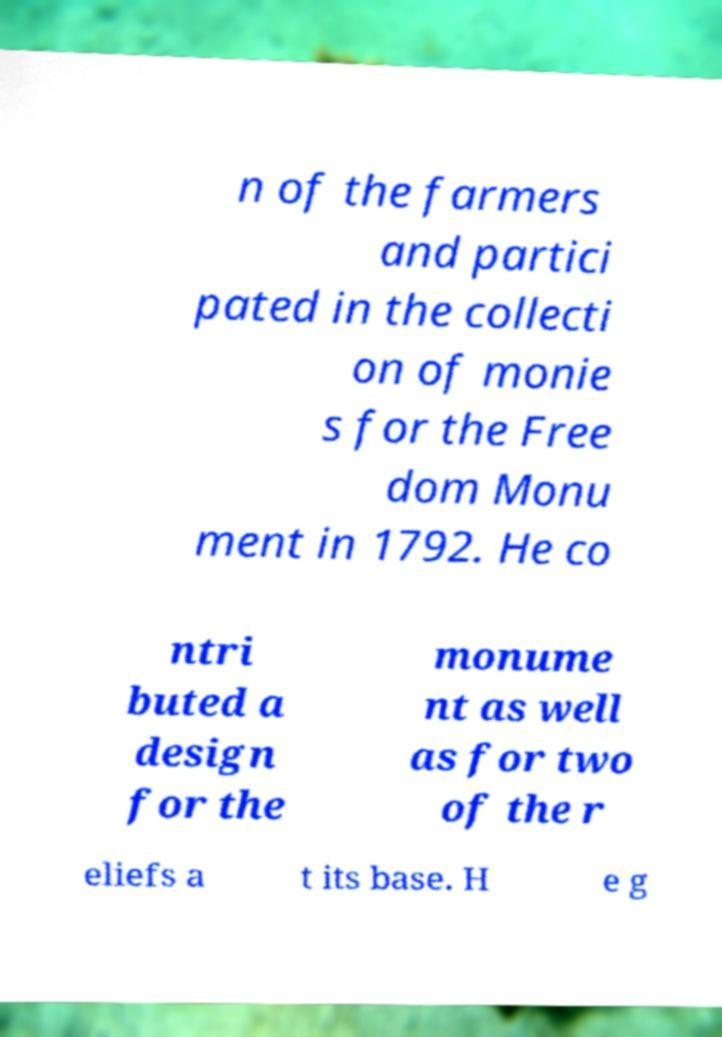Please identify and transcribe the text found in this image. n of the farmers and partici pated in the collecti on of monie s for the Free dom Monu ment in 1792. He co ntri buted a design for the monume nt as well as for two of the r eliefs a t its base. H e g 